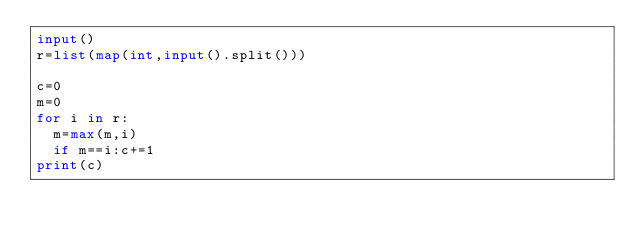<code> <loc_0><loc_0><loc_500><loc_500><_Python_>input()
r=list(map(int,input().split()))

c=0
m=0
for i in r:
  m=max(m,i)
  if m==i:c+=1
print(c)</code> 